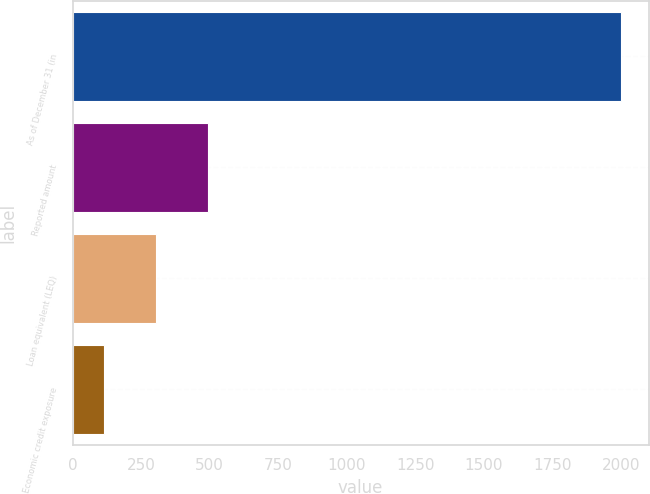<chart> <loc_0><loc_0><loc_500><loc_500><bar_chart><fcel>As of December 31 (in<fcel>Reported amount<fcel>Loan equivalent (LEQ)<fcel>Economic credit exposure<nl><fcel>2002<fcel>492.4<fcel>303.7<fcel>115<nl></chart> 